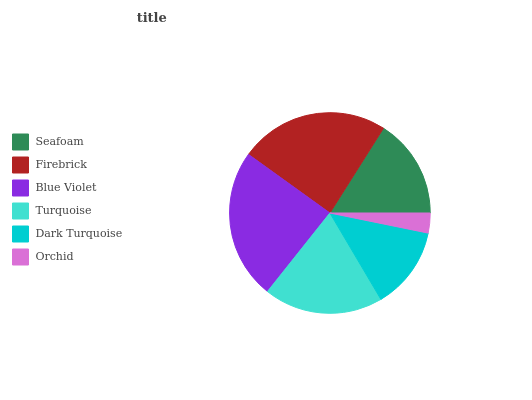Is Orchid the minimum?
Answer yes or no. Yes. Is Blue Violet the maximum?
Answer yes or no. Yes. Is Firebrick the minimum?
Answer yes or no. No. Is Firebrick the maximum?
Answer yes or no. No. Is Firebrick greater than Seafoam?
Answer yes or no. Yes. Is Seafoam less than Firebrick?
Answer yes or no. Yes. Is Seafoam greater than Firebrick?
Answer yes or no. No. Is Firebrick less than Seafoam?
Answer yes or no. No. Is Turquoise the high median?
Answer yes or no. Yes. Is Seafoam the low median?
Answer yes or no. Yes. Is Orchid the high median?
Answer yes or no. No. Is Turquoise the low median?
Answer yes or no. No. 